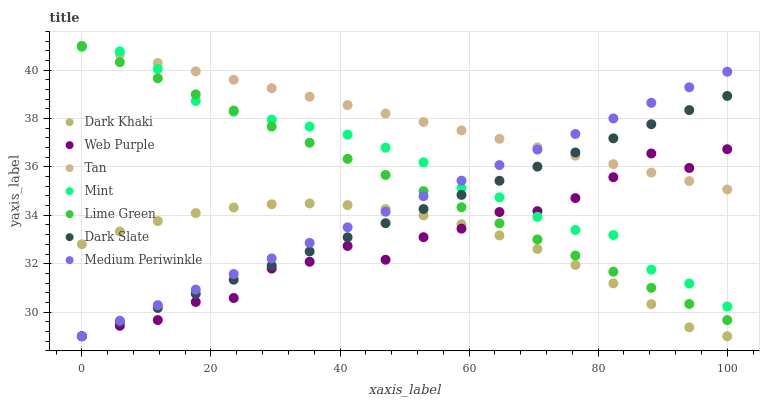Does Web Purple have the minimum area under the curve?
Answer yes or no. Yes. Does Tan have the maximum area under the curve?
Answer yes or no. Yes. Does Medium Periwinkle have the minimum area under the curve?
Answer yes or no. No. Does Medium Periwinkle have the maximum area under the curve?
Answer yes or no. No. Is Tan the smoothest?
Answer yes or no. Yes. Is Web Purple the roughest?
Answer yes or no. Yes. Is Medium Periwinkle the smoothest?
Answer yes or no. No. Is Medium Periwinkle the roughest?
Answer yes or no. No. Does Medium Periwinkle have the lowest value?
Answer yes or no. Yes. Does Tan have the lowest value?
Answer yes or no. No. Does Lime Green have the highest value?
Answer yes or no. Yes. Does Medium Periwinkle have the highest value?
Answer yes or no. No. Is Dark Khaki less than Mint?
Answer yes or no. Yes. Is Lime Green greater than Dark Khaki?
Answer yes or no. Yes. Does Tan intersect Medium Periwinkle?
Answer yes or no. Yes. Is Tan less than Medium Periwinkle?
Answer yes or no. No. Is Tan greater than Medium Periwinkle?
Answer yes or no. No. Does Dark Khaki intersect Mint?
Answer yes or no. No. 